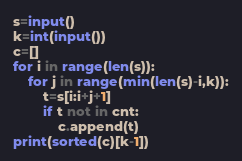Convert code to text. <code><loc_0><loc_0><loc_500><loc_500><_Python_>s=input()
k=int(input())
c=[]
for i in range(len(s)):
    for j in range(min(len(s)-i,k)):
        t=s[i:i+j+1]
        if t not in cnt:
            c.append(t)
print(sorted(c)[k-1])</code> 